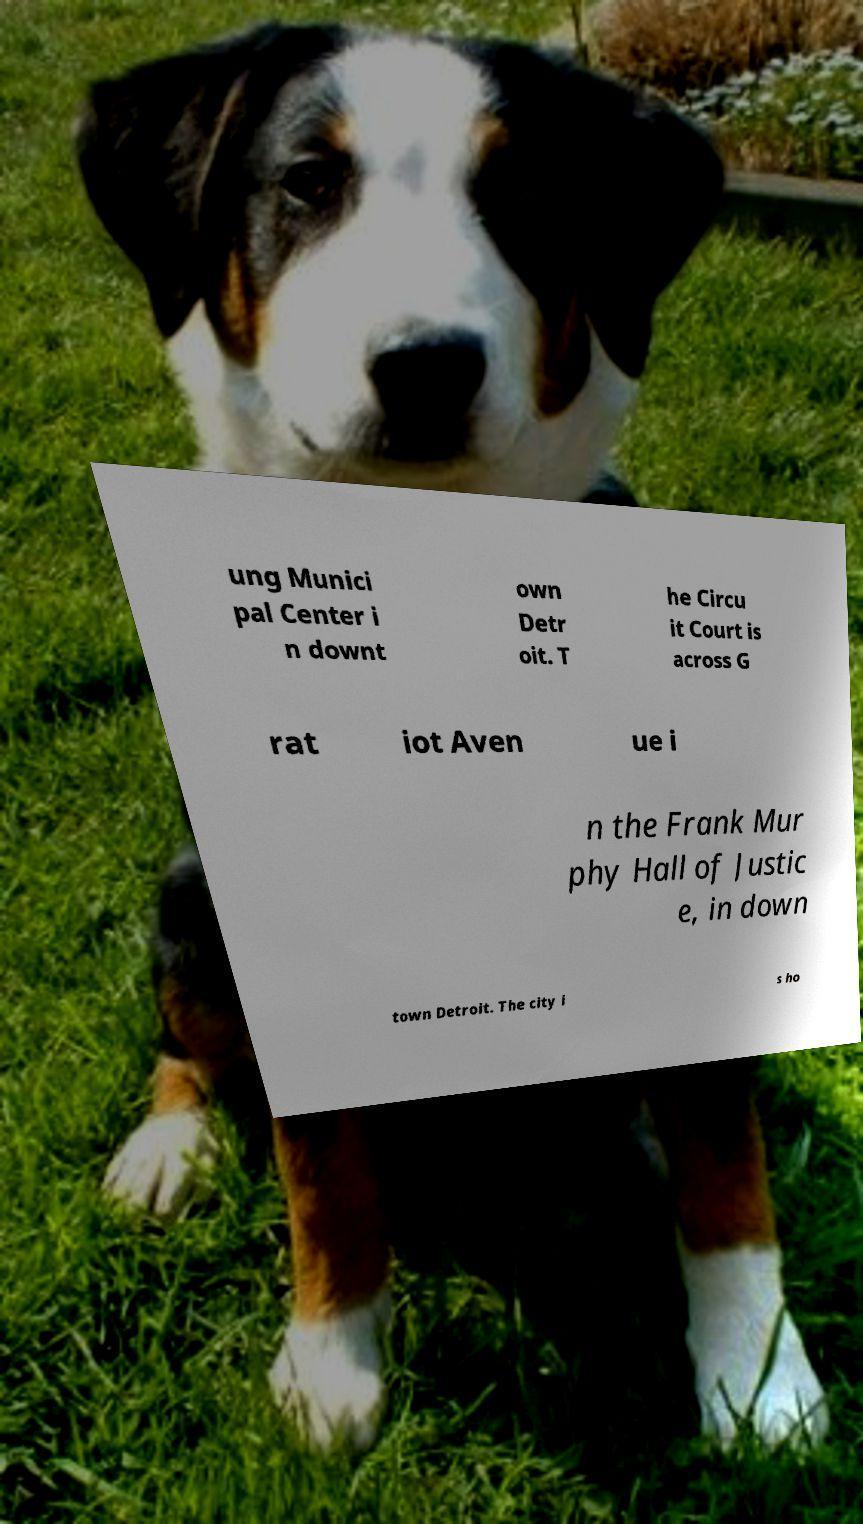Can you read and provide the text displayed in the image?This photo seems to have some interesting text. Can you extract and type it out for me? ung Munici pal Center i n downt own Detr oit. T he Circu it Court is across G rat iot Aven ue i n the Frank Mur phy Hall of Justic e, in down town Detroit. The city i s ho 